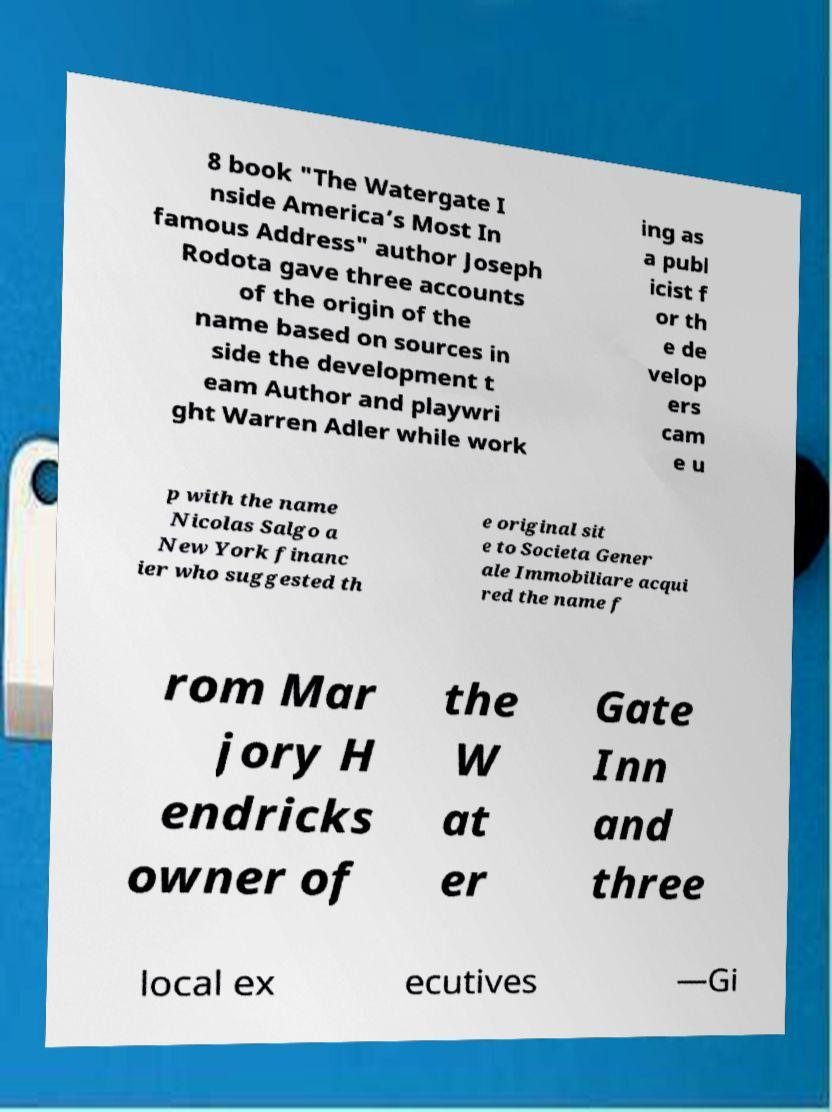For documentation purposes, I need the text within this image transcribed. Could you provide that? 8 book "The Watergate I nside America’s Most In famous Address" author Joseph Rodota gave three accounts of the origin of the name based on sources in side the development t eam Author and playwri ght Warren Adler while work ing as a publ icist f or th e de velop ers cam e u p with the name Nicolas Salgo a New York financ ier who suggested th e original sit e to Societa Gener ale Immobiliare acqui red the name f rom Mar jory H endricks owner of the W at er Gate Inn and three local ex ecutives —Gi 